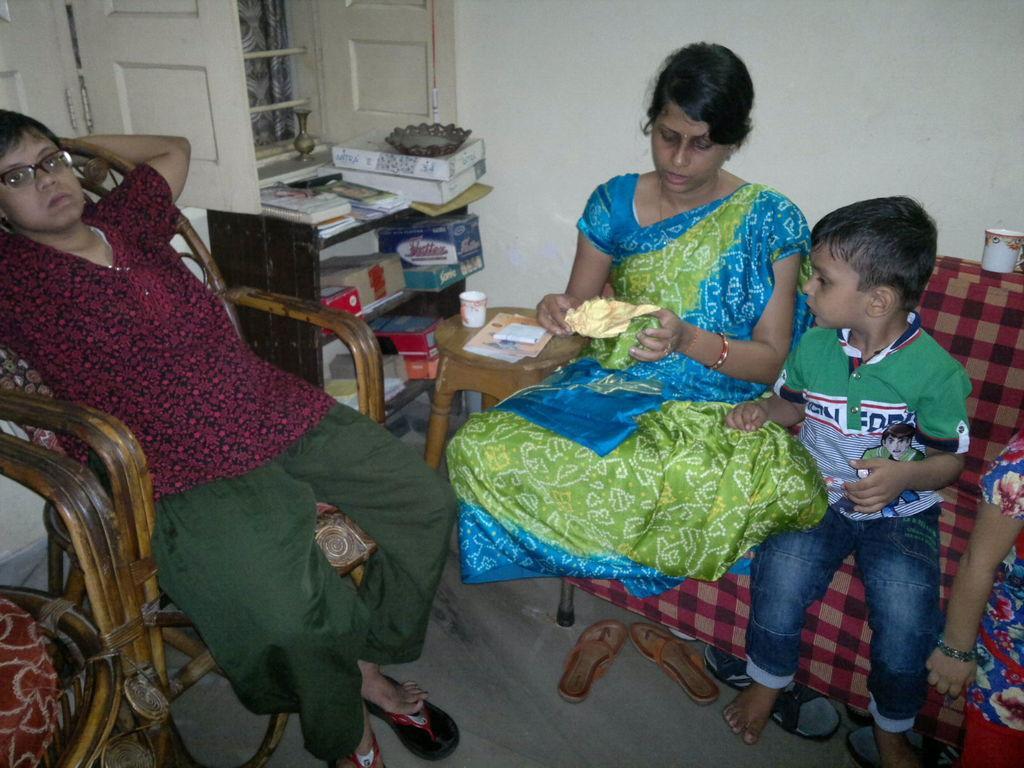In one or two sentences, can you explain what this image depicts? In this image i can see two women sitting on a chair and a child sitting beside her, at the left there are few papers, cup on a table, there are few card boards on a shelf, a window at the back ground i can see a curtain and a wall. 